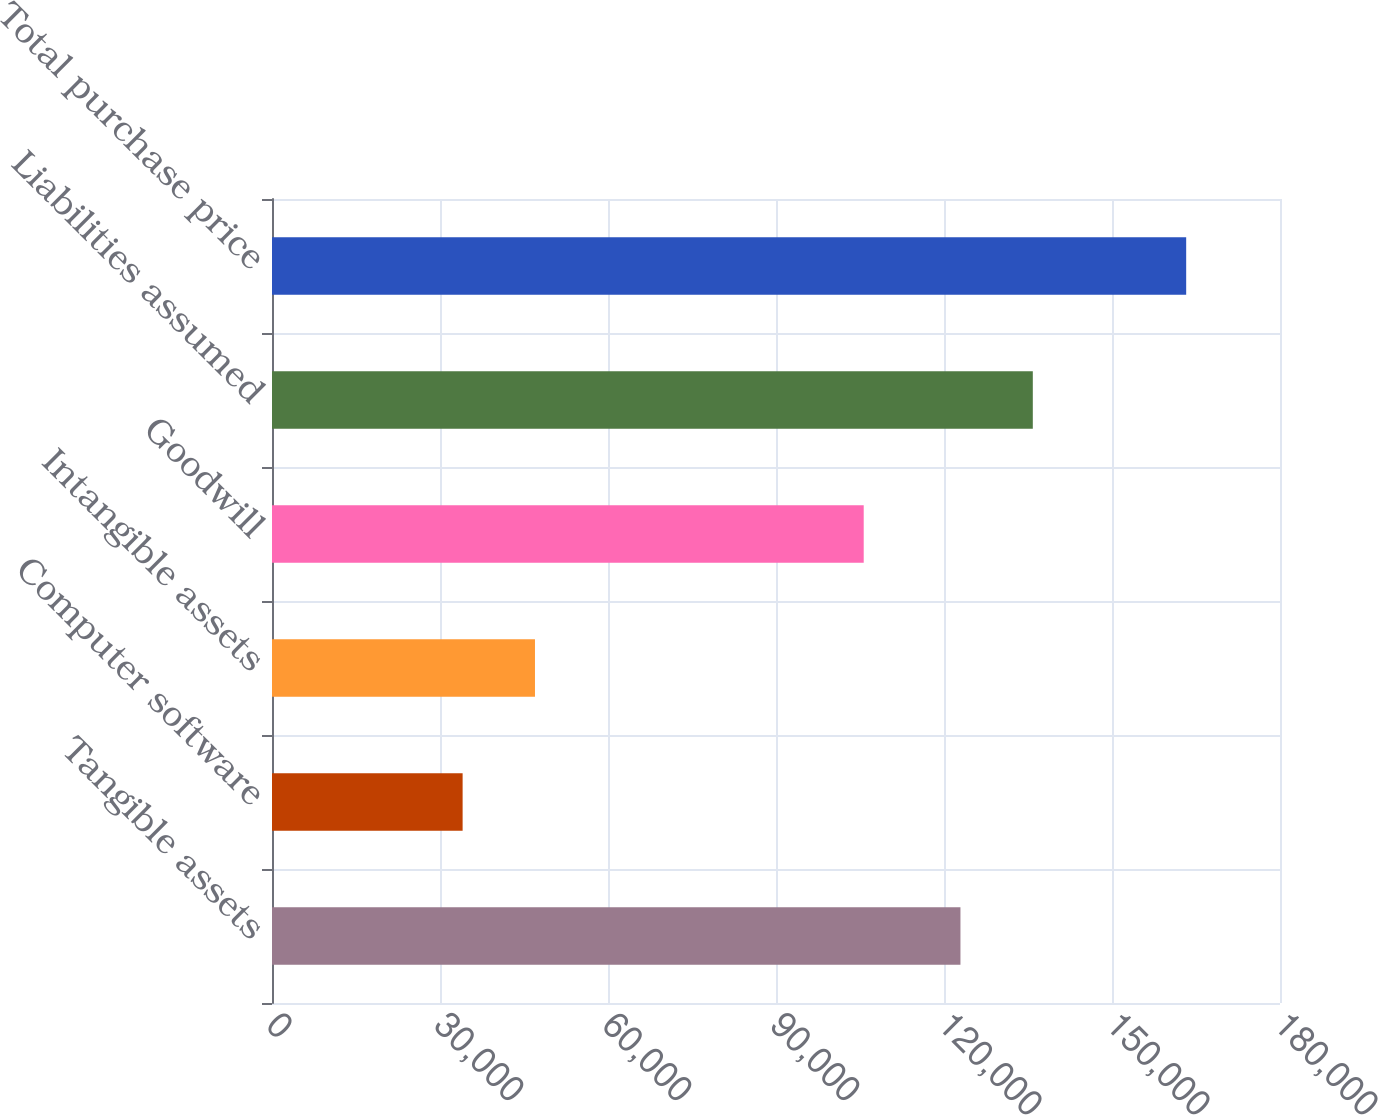Convert chart to OTSL. <chart><loc_0><loc_0><loc_500><loc_500><bar_chart><fcel>Tangible assets<fcel>Computer software<fcel>Intangible assets<fcel>Goodwill<fcel>Liabilities assumed<fcel>Total purchase price<nl><fcel>122938<fcel>34039<fcel>46959.7<fcel>105664<fcel>135859<fcel>163246<nl></chart> 